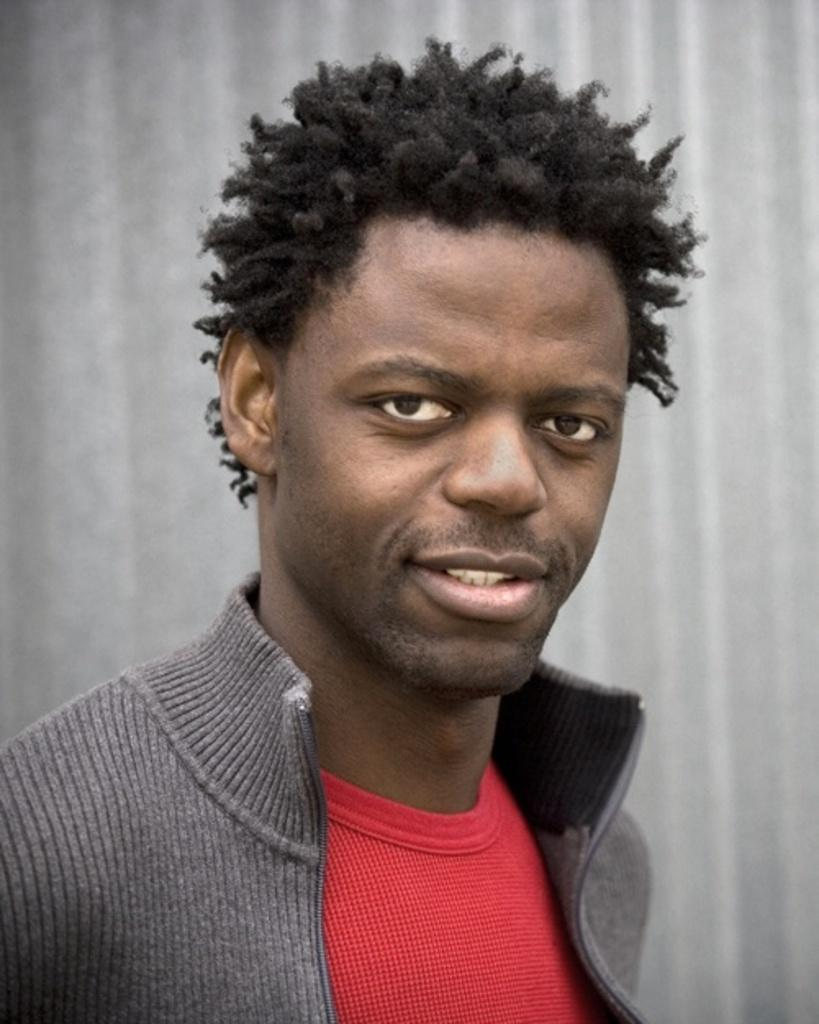What is the main subject of the image? There is a person in the image. What is the person wearing on their upper body? The person is wearing a gray jacket and a red T-shirt. What is the facial expression of the person? The person is smiling. What color is predominant in the background of the image? The background of the image is in gray color. What type of meal is the person eating in the image? There is no meal present in the image; the person is not eating anything. What is the person's expertise in the image? There is no indication of the person's expertise in the image. 